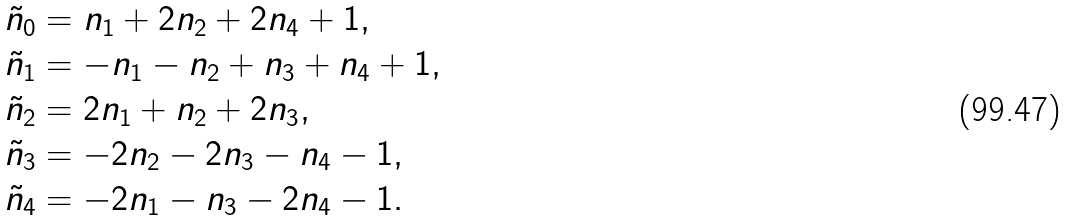Convert formula to latex. <formula><loc_0><loc_0><loc_500><loc_500>\tilde { n } _ { 0 } & = n _ { 1 } + 2 n _ { 2 } + 2 n _ { 4 } + 1 , \\ \tilde { n } _ { 1 } & = - n _ { 1 } - n _ { 2 } + n _ { 3 } + n _ { 4 } + 1 , \\ \tilde { n } _ { 2 } & = 2 n _ { 1 } + n _ { 2 } + 2 n _ { 3 } , \\ \tilde { n } _ { 3 } & = - 2 n _ { 2 } - 2 n _ { 3 } - n _ { 4 } - 1 , \\ \tilde { n } _ { 4 } & = - 2 n _ { 1 } - n _ { 3 } - 2 n _ { 4 } - 1 . \\</formula> 